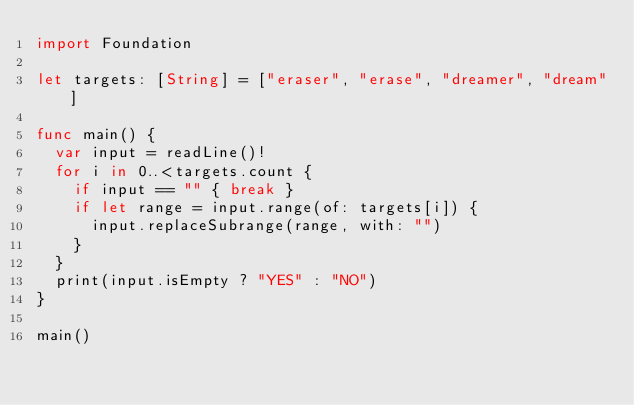<code> <loc_0><loc_0><loc_500><loc_500><_Swift_>import Foundation

let targets: [String] = ["eraser", "erase", "dreamer", "dream"]

func main() {
	var input = readLine()!
	for i in 0..<targets.count {
		if input == "" { break }
		if let range = input.range(of: targets[i]) {
			input.replaceSubrange(range, with: "")
		}
	}
	print(input.isEmpty ? "YES" : "NO")
}

main()
</code> 